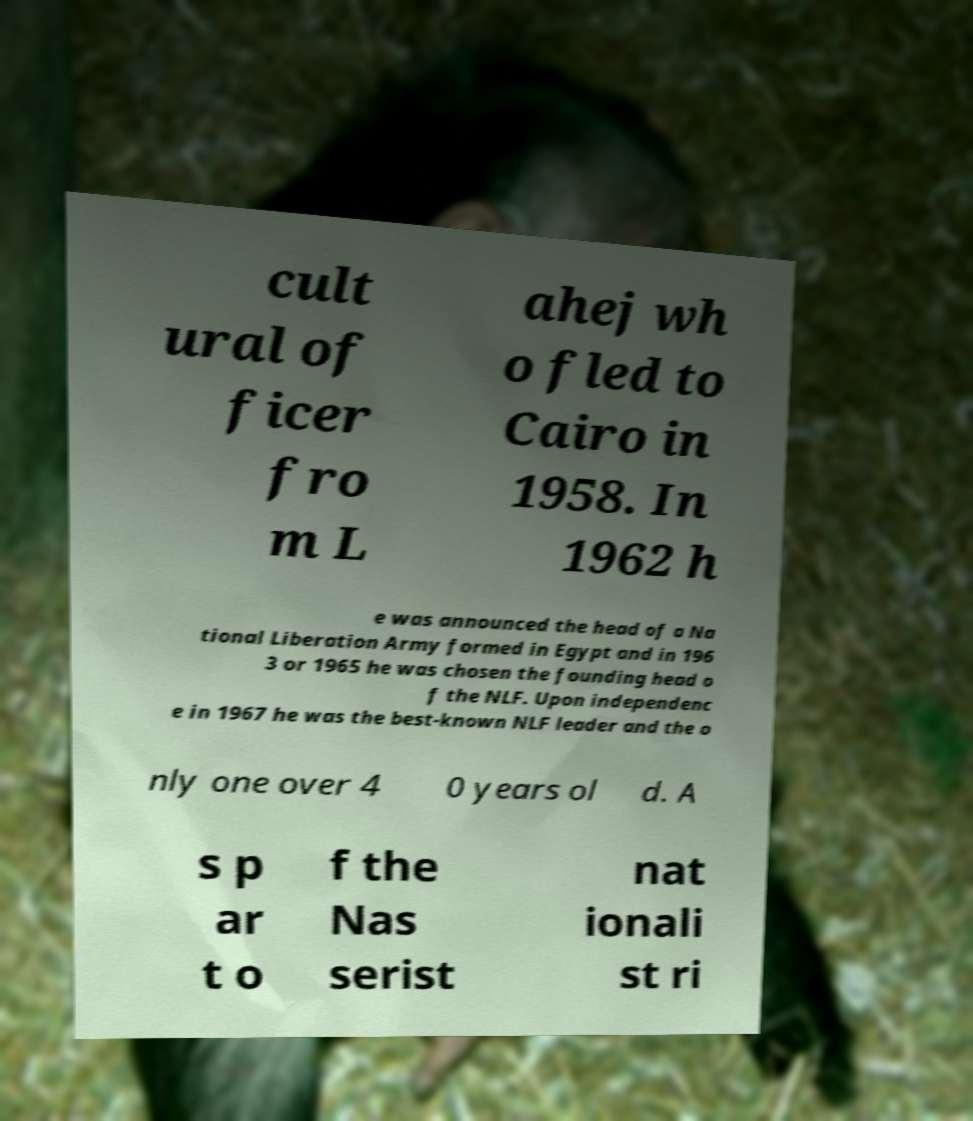There's text embedded in this image that I need extracted. Can you transcribe it verbatim? cult ural of ficer fro m L ahej wh o fled to Cairo in 1958. In 1962 h e was announced the head of a Na tional Liberation Army formed in Egypt and in 196 3 or 1965 he was chosen the founding head o f the NLF. Upon independenc e in 1967 he was the best-known NLF leader and the o nly one over 4 0 years ol d. A s p ar t o f the Nas serist nat ionali st ri 